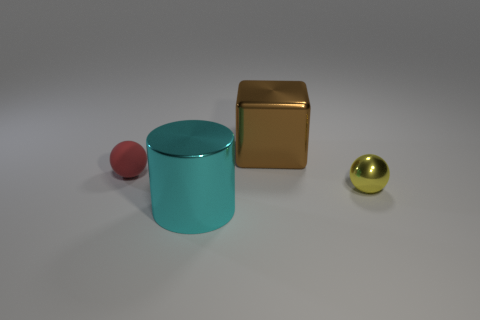What is the shape of the large cyan thing? cylinder 